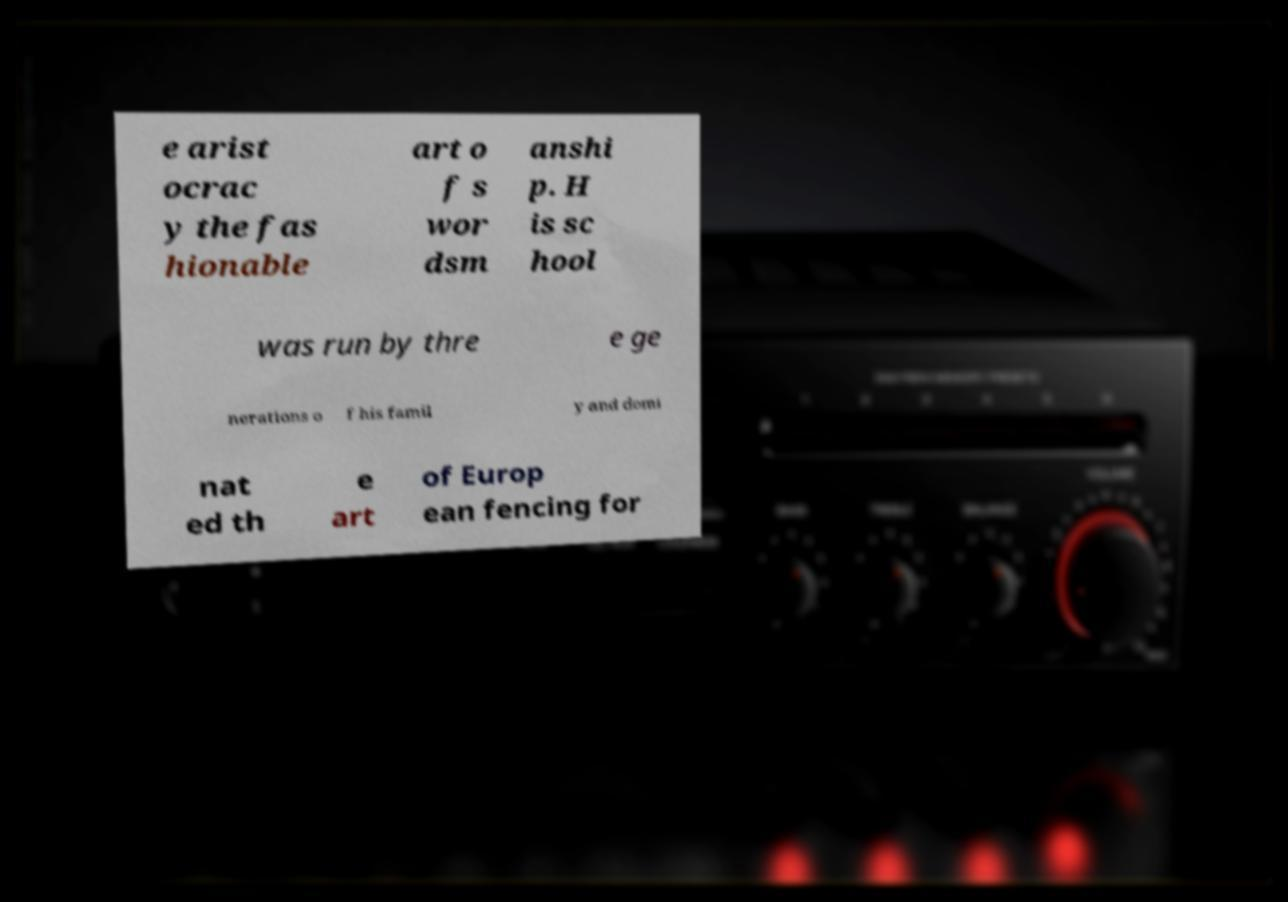Please read and relay the text visible in this image. What does it say? e arist ocrac y the fas hionable art o f s wor dsm anshi p. H is sc hool was run by thre e ge nerations o f his famil y and domi nat ed th e art of Europ ean fencing for 